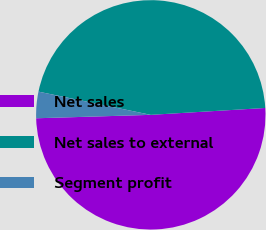<chart> <loc_0><loc_0><loc_500><loc_500><pie_chart><fcel>Net sales<fcel>Net sales to external<fcel>Segment profit<nl><fcel>50.48%<fcel>45.8%<fcel>3.72%<nl></chart> 